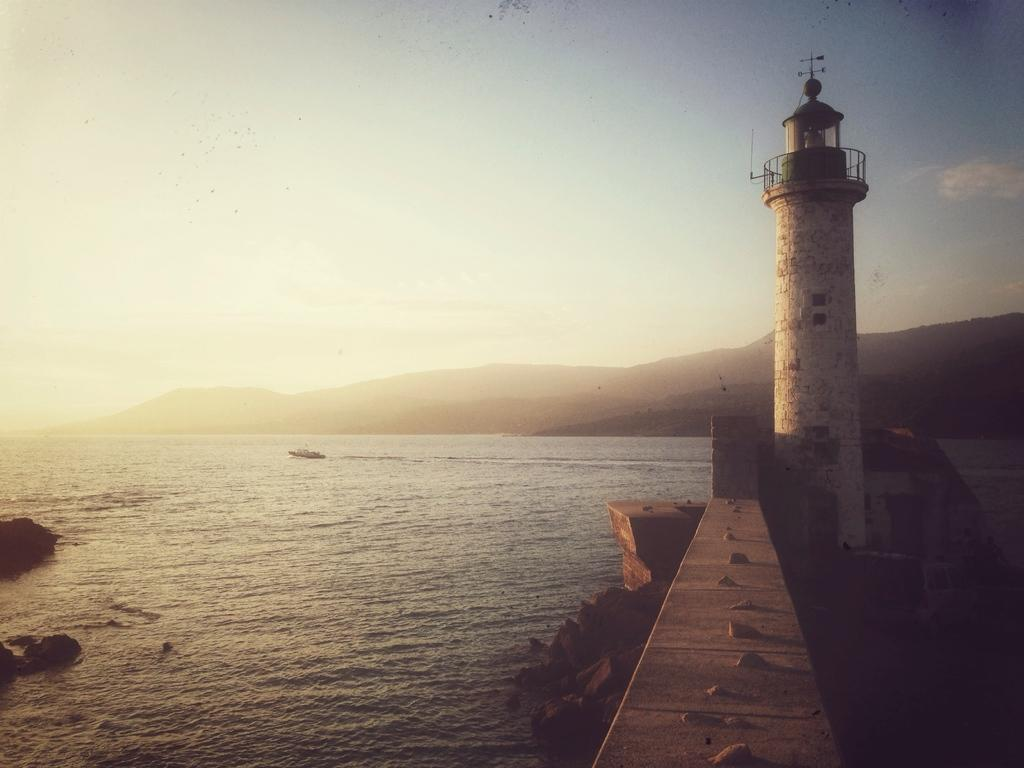What type of natural feature can be seen in the image? There is a sea in the image. What other geographical features are present in the image? There are hills in the image. What is visible in the sky in the image? The sky is visible in the image. What type of structure can be seen in the image? There is a lighthouse in the image. What type of terrain is present in the image? Rocks are present in the image. What type of lettuce is growing near the lighthouse in the image? There is no lettuce present in the image; it features a sea, hills, sky, a lighthouse, and rocks. 